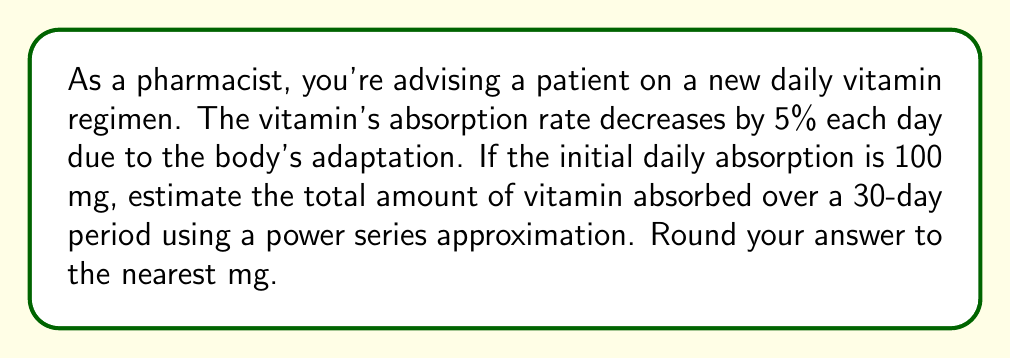Show me your answer to this math problem. Let's approach this step-by-step using a power series:

1) Let $r = 0.95$ (95% absorption rate each subsequent day)

2) The daily absorption can be modeled as a geometric sequence:
   Day 1: $100$ mg
   Day 2: $100r$ mg
   Day 3: $100r^2$ mg
   ...
   Day n: $100r^{n-1}$ mg

3) The total absorption over 30 days is the sum of this geometric sequence:

   $$S_{30} = 100 + 100r + 100r^2 + ... + 100r^{29}$$

4) This is a geometric series with first term $a = 100$ and common ratio $r = 0.95$

5) The sum of a geometric series is given by the formula:
   $$S_n = \frac{a(1-r^n)}{1-r}$$ where $n = 30$

6) Substituting our values:

   $$S_{30} = \frac{100(1-0.95^{30})}{1-0.95}$$

7) Calculating:
   $$S_{30} = \frac{100(1-0.2146)}{0.05} = \frac{100(0.7854)}{0.05} = 1570.8$$

8) Rounding to the nearest mg:
   $$S_{30} \approx 1571 \text{ mg}$$
Answer: 1571 mg 